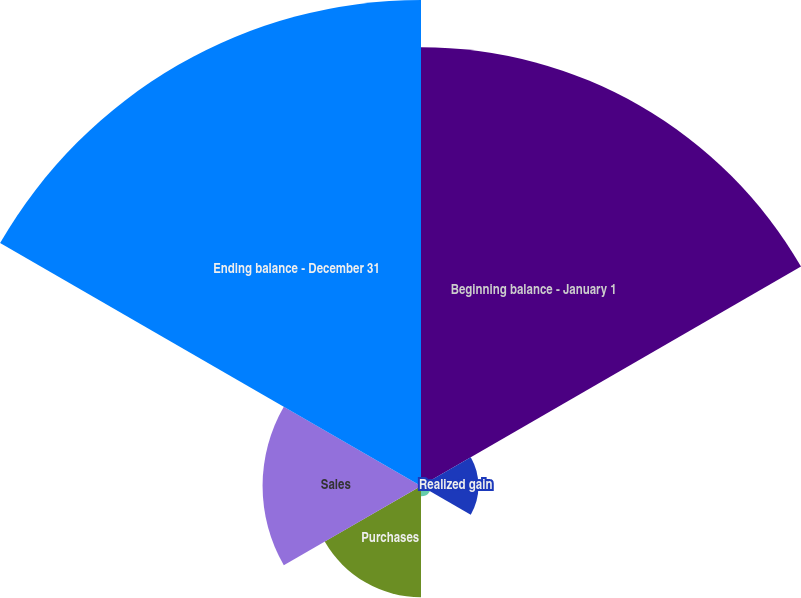Convert chart. <chart><loc_0><loc_0><loc_500><loc_500><pie_chart><fcel>Beginning balance - January 1<fcel>Realized gain<fcel>Unrealized gain<fcel>Purchases<fcel>Sales<fcel>Ending balance - December 31<nl><fcel>34.76%<fcel>4.55%<fcel>0.82%<fcel>8.81%<fcel>12.55%<fcel>38.5%<nl></chart> 